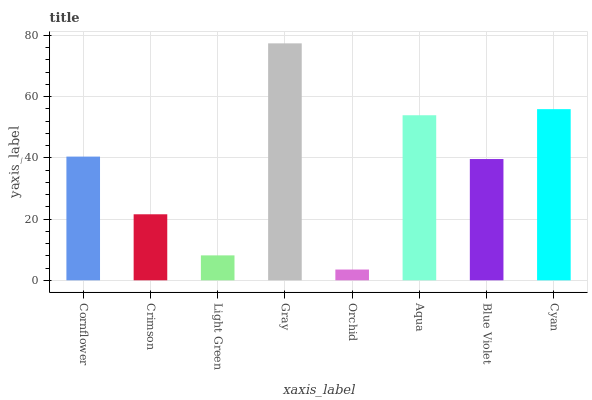Is Crimson the minimum?
Answer yes or no. No. Is Crimson the maximum?
Answer yes or no. No. Is Cornflower greater than Crimson?
Answer yes or no. Yes. Is Crimson less than Cornflower?
Answer yes or no. Yes. Is Crimson greater than Cornflower?
Answer yes or no. No. Is Cornflower less than Crimson?
Answer yes or no. No. Is Cornflower the high median?
Answer yes or no. Yes. Is Blue Violet the low median?
Answer yes or no. Yes. Is Aqua the high median?
Answer yes or no. No. Is Light Green the low median?
Answer yes or no. No. 